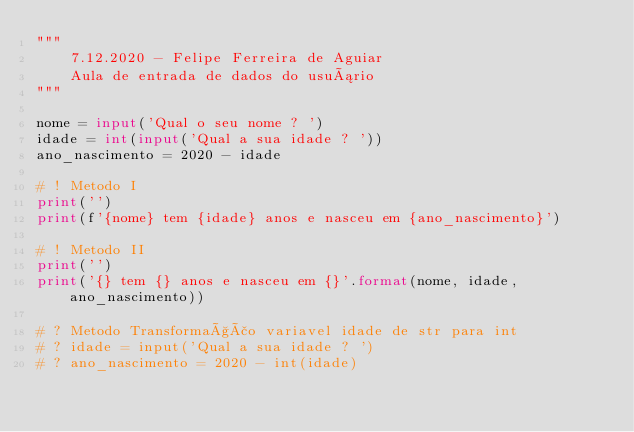<code> <loc_0><loc_0><loc_500><loc_500><_Python_>"""
    7.12.2020 - Felipe Ferreira de Aguiar
    Aula de entrada de dados do usuário
"""

nome = input('Qual o seu nome ? ')
idade = int(input('Qual a sua idade ? '))
ano_nascimento = 2020 - idade

# ! Metodo I
print('')
print(f'{nome} tem {idade} anos e nasceu em {ano_nascimento}')

# ! Metodo II
print('')
print('{} tem {} anos e nasceu em {}'.format(nome, idade, ano_nascimento))

# ? Metodo Transformação variavel idade de str para int
# ? idade = input('Qual a sua idade ? ')
# ? ano_nascimento = 2020 - int(idade)
</code> 